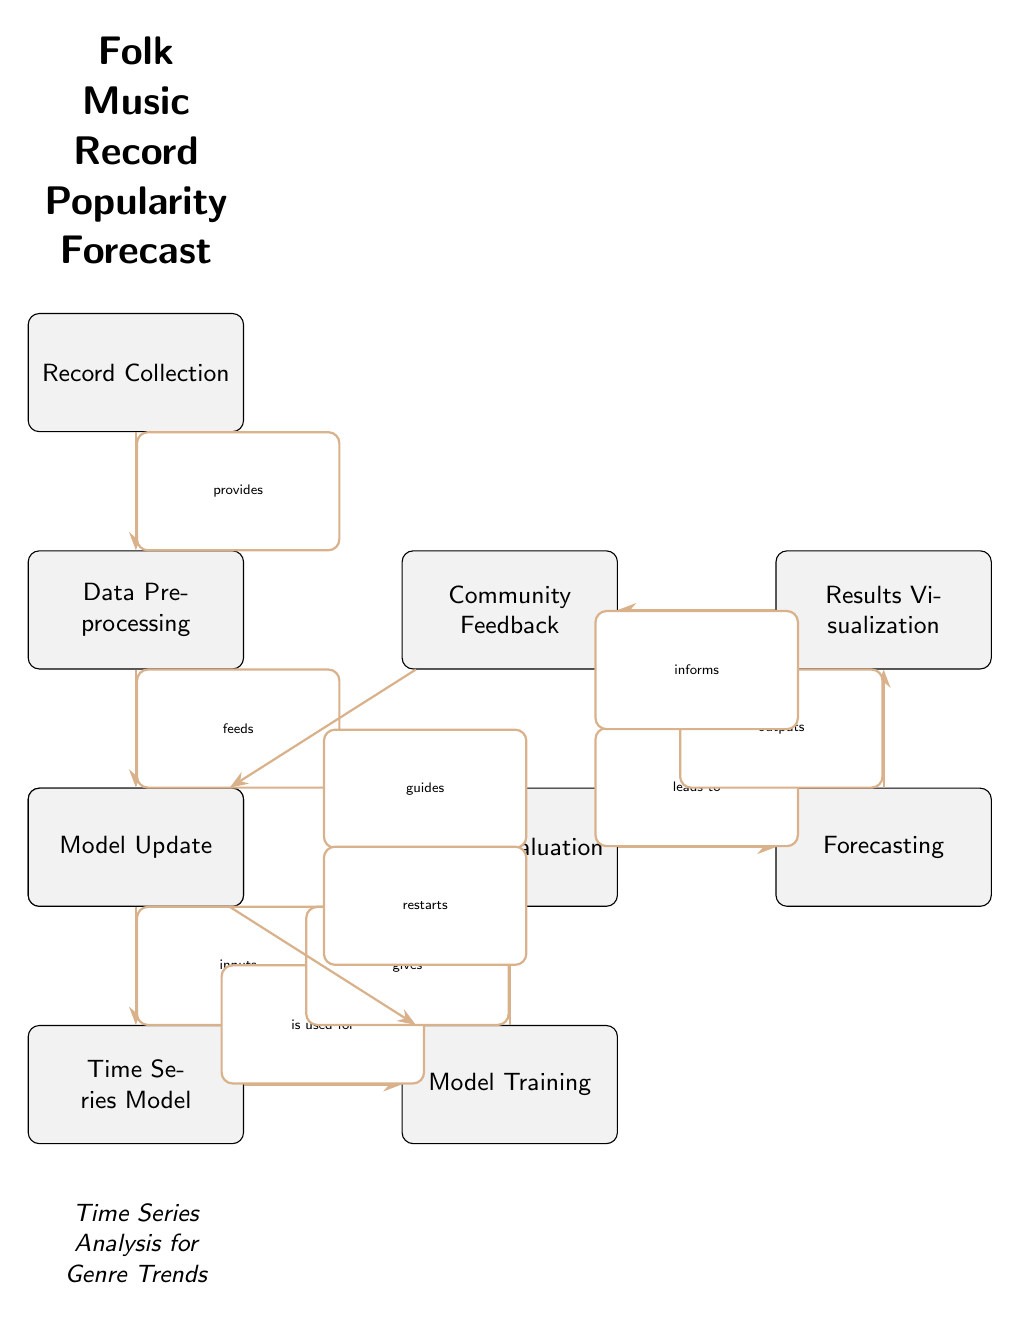What is the starting point of the diagram? The diagram starts with the node "Record Collection," which provides data to the next step in the process.
Answer: Record Collection How many nodes are in the diagram? By counting the distinct boxes (nodes) in the diagram, there are a total of 9 nodes present.
Answer: 9 What is the relationship between "Forecasting" and "Results Visualization"? "Forecasting" leads to "Results Visualization" as indicated by the directed edge labeled "outputs."
Answer: leads to What does "Community Feedback" inform? According to the diagram, "Community Feedback" informs "Results Visualization." This is shown by the directed edge leading from "Community Feedback" to "Results Visualization."
Answer: Results Visualization What process follows after "Model Evaluation"? After "Model Evaluation," the next step is "Forecasting," which follows directly based on the directed edge labeled "leads to."
Answer: Forecasting How does "Model Update" influence the process? "Model Update" guides "Model Training," indicating that feedback from the community is used to restart the training of the model for better predictions.
Answer: guides What precedes "Model Training" in the diagram? The step immediately preceding "Model Training" is "Time Series Model," which is used for training the model as indicated by the edge labeled "is used for."
Answer: Time Series Model Which node provides input for "Data Preprocessing"? The input for "Data Preprocessing" comes directly from the "Record Collection" node, as shown by the directed edge labeled "provides."
Answer: Record Collection What is the ultimate goal of this diagram? The ultimate goal of the diagram, indicated at the top, is to forecast the popularity of folk music records.
Answer: Folk Music Record Popularity Forecast 